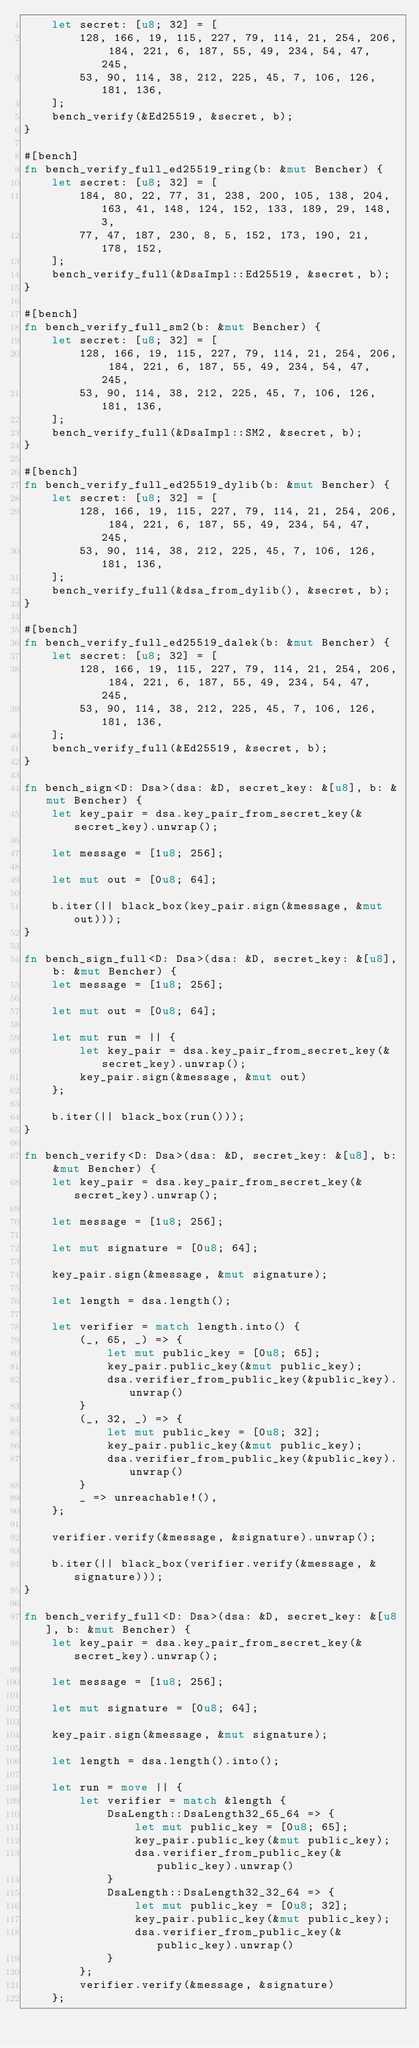Convert code to text. <code><loc_0><loc_0><loc_500><loc_500><_Rust_>	let secret: [u8; 32] = [
		128, 166, 19, 115, 227, 79, 114, 21, 254, 206, 184, 221, 6, 187, 55, 49, 234, 54, 47, 245,
		53, 90, 114, 38, 212, 225, 45, 7, 106, 126, 181, 136,
	];
	bench_verify(&Ed25519, &secret, b);
}

#[bench]
fn bench_verify_full_ed25519_ring(b: &mut Bencher) {
	let secret: [u8; 32] = [
		184, 80, 22, 77, 31, 238, 200, 105, 138, 204, 163, 41, 148, 124, 152, 133, 189, 29, 148, 3,
		77, 47, 187, 230, 8, 5, 152, 173, 190, 21, 178, 152,
	];
	bench_verify_full(&DsaImpl::Ed25519, &secret, b);
}

#[bench]
fn bench_verify_full_sm2(b: &mut Bencher) {
	let secret: [u8; 32] = [
		128, 166, 19, 115, 227, 79, 114, 21, 254, 206, 184, 221, 6, 187, 55, 49, 234, 54, 47, 245,
		53, 90, 114, 38, 212, 225, 45, 7, 106, 126, 181, 136,
	];
	bench_verify_full(&DsaImpl::SM2, &secret, b);
}

#[bench]
fn bench_verify_full_ed25519_dylib(b: &mut Bencher) {
	let secret: [u8; 32] = [
		128, 166, 19, 115, 227, 79, 114, 21, 254, 206, 184, 221, 6, 187, 55, 49, 234, 54, 47, 245,
		53, 90, 114, 38, 212, 225, 45, 7, 106, 126, 181, 136,
	];
	bench_verify_full(&dsa_from_dylib(), &secret, b);
}

#[bench]
fn bench_verify_full_ed25519_dalek(b: &mut Bencher) {
	let secret: [u8; 32] = [
		128, 166, 19, 115, 227, 79, 114, 21, 254, 206, 184, 221, 6, 187, 55, 49, 234, 54, 47, 245,
		53, 90, 114, 38, 212, 225, 45, 7, 106, 126, 181, 136,
	];
	bench_verify_full(&Ed25519, &secret, b);
}

fn bench_sign<D: Dsa>(dsa: &D, secret_key: &[u8], b: &mut Bencher) {
	let key_pair = dsa.key_pair_from_secret_key(&secret_key).unwrap();

	let message = [1u8; 256];

	let mut out = [0u8; 64];

	b.iter(|| black_box(key_pair.sign(&message, &mut out)));
}

fn bench_sign_full<D: Dsa>(dsa: &D, secret_key: &[u8], b: &mut Bencher) {
	let message = [1u8; 256];

	let mut out = [0u8; 64];

	let mut run = || {
		let key_pair = dsa.key_pair_from_secret_key(&secret_key).unwrap();
		key_pair.sign(&message, &mut out)
	};

	b.iter(|| black_box(run()));
}

fn bench_verify<D: Dsa>(dsa: &D, secret_key: &[u8], b: &mut Bencher) {
	let key_pair = dsa.key_pair_from_secret_key(&secret_key).unwrap();

	let message = [1u8; 256];

	let mut signature = [0u8; 64];

	key_pair.sign(&message, &mut signature);

	let length = dsa.length();

	let verifier = match length.into() {
		(_, 65, _) => {
			let mut public_key = [0u8; 65];
			key_pair.public_key(&mut public_key);
			dsa.verifier_from_public_key(&public_key).unwrap()
		}
		(_, 32, _) => {
			let mut public_key = [0u8; 32];
			key_pair.public_key(&mut public_key);
			dsa.verifier_from_public_key(&public_key).unwrap()
		}
		_ => unreachable!(),
	};

	verifier.verify(&message, &signature).unwrap();

	b.iter(|| black_box(verifier.verify(&message, &signature)));
}

fn bench_verify_full<D: Dsa>(dsa: &D, secret_key: &[u8], b: &mut Bencher) {
	let key_pair = dsa.key_pair_from_secret_key(&secret_key).unwrap();

	let message = [1u8; 256];

	let mut signature = [0u8; 64];

	key_pair.sign(&message, &mut signature);

	let length = dsa.length().into();

	let run = move || {
		let verifier = match &length {
			DsaLength::DsaLength32_65_64 => {
				let mut public_key = [0u8; 65];
				key_pair.public_key(&mut public_key);
				dsa.verifier_from_public_key(&public_key).unwrap()
			}
			DsaLength::DsaLength32_32_64 => {
				let mut public_key = [0u8; 32];
				key_pair.public_key(&mut public_key);
				dsa.verifier_from_public_key(&public_key).unwrap()
			}
		};
		verifier.verify(&message, &signature)
	};
</code> 